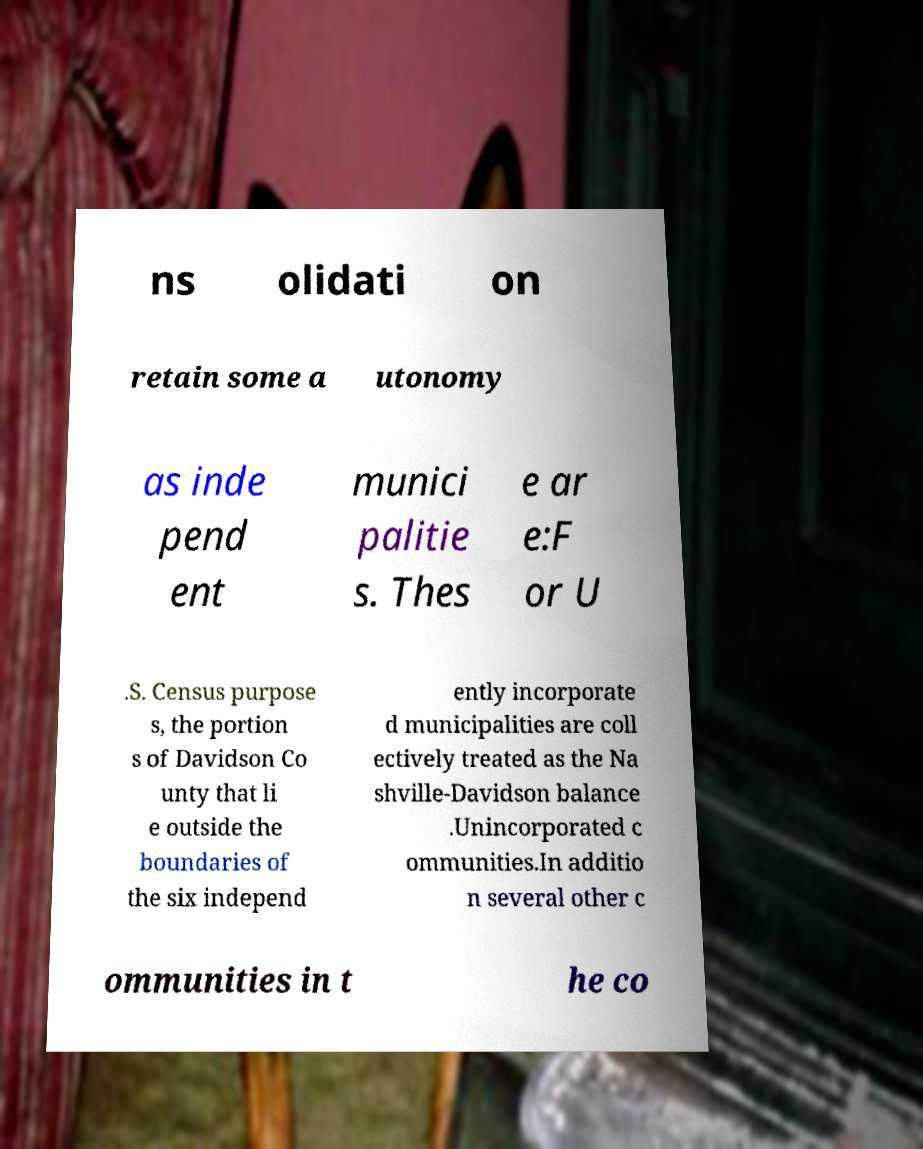For documentation purposes, I need the text within this image transcribed. Could you provide that? ns olidati on retain some a utonomy as inde pend ent munici palitie s. Thes e ar e:F or U .S. Census purpose s, the portion s of Davidson Co unty that li e outside the boundaries of the six independ ently incorporate d municipalities are coll ectively treated as the Na shville-Davidson balance .Unincorporated c ommunities.In additio n several other c ommunities in t he co 